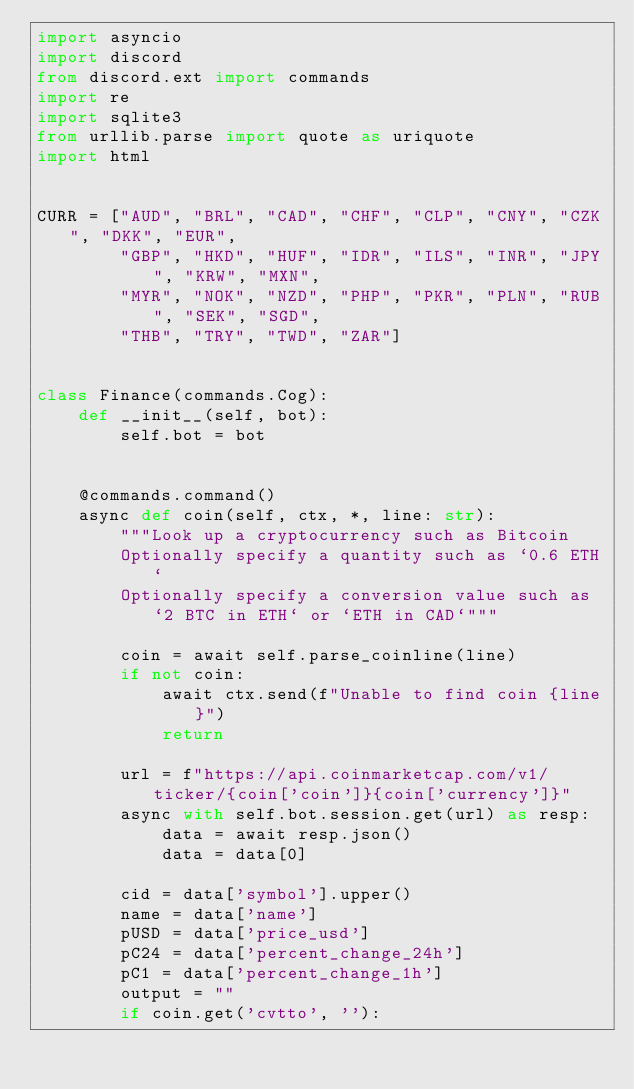Convert code to text. <code><loc_0><loc_0><loc_500><loc_500><_Python_>import asyncio
import discord
from discord.ext import commands
import re
import sqlite3
from urllib.parse import quote as uriquote
import html


CURR = ["AUD", "BRL", "CAD", "CHF", "CLP", "CNY", "CZK", "DKK", "EUR", 
        "GBP", "HKD", "HUF", "IDR", "ILS", "INR", "JPY", "KRW", "MXN", 
        "MYR", "NOK", "NZD", "PHP", "PKR", "PLN", "RUB", "SEK", "SGD", 
        "THB", "TRY", "TWD", "ZAR"]


class Finance(commands.Cog):
    def __init__(self, bot):
        self.bot = bot


    @commands.command()
    async def coin(self, ctx, *, line: str):
        """Look up a cryptocurrency such as Bitcoin
        Optionally specify a quantity such as `0.6 ETH`
        Optionally specify a conversion value such as `2 BTC in ETH` or `ETH in CAD`"""

        coin = await self.parse_coinline(line)
        if not coin:
            await ctx.send(f"Unable to find coin {line}")
            return

        url = f"https://api.coinmarketcap.com/v1/ticker/{coin['coin']}{coin['currency']}"
        async with self.bot.session.get(url) as resp:
            data = await resp.json()
            data = data[0]

        cid = data['symbol'].upper()
        name = data['name']
        pUSD = data['price_usd']
        pC24 = data['percent_change_24h']
        pC1 = data['percent_change_1h']
        output = ""
        if coin.get('cvtto', ''):</code> 